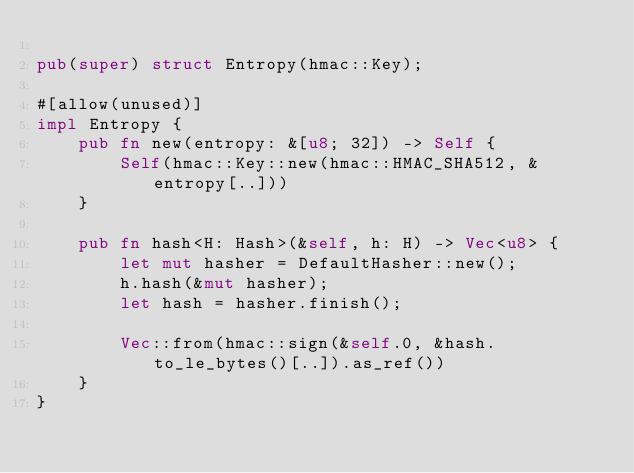<code> <loc_0><loc_0><loc_500><loc_500><_Rust_>
pub(super) struct Entropy(hmac::Key);

#[allow(unused)]
impl Entropy {
    pub fn new(entropy: &[u8; 32]) -> Self {
        Self(hmac::Key::new(hmac::HMAC_SHA512, &entropy[..]))
    }

    pub fn hash<H: Hash>(&self, h: H) -> Vec<u8> {
        let mut hasher = DefaultHasher::new();
        h.hash(&mut hasher);
        let hash = hasher.finish();

        Vec::from(hmac::sign(&self.0, &hash.to_le_bytes()[..]).as_ref())
    }
}
</code> 